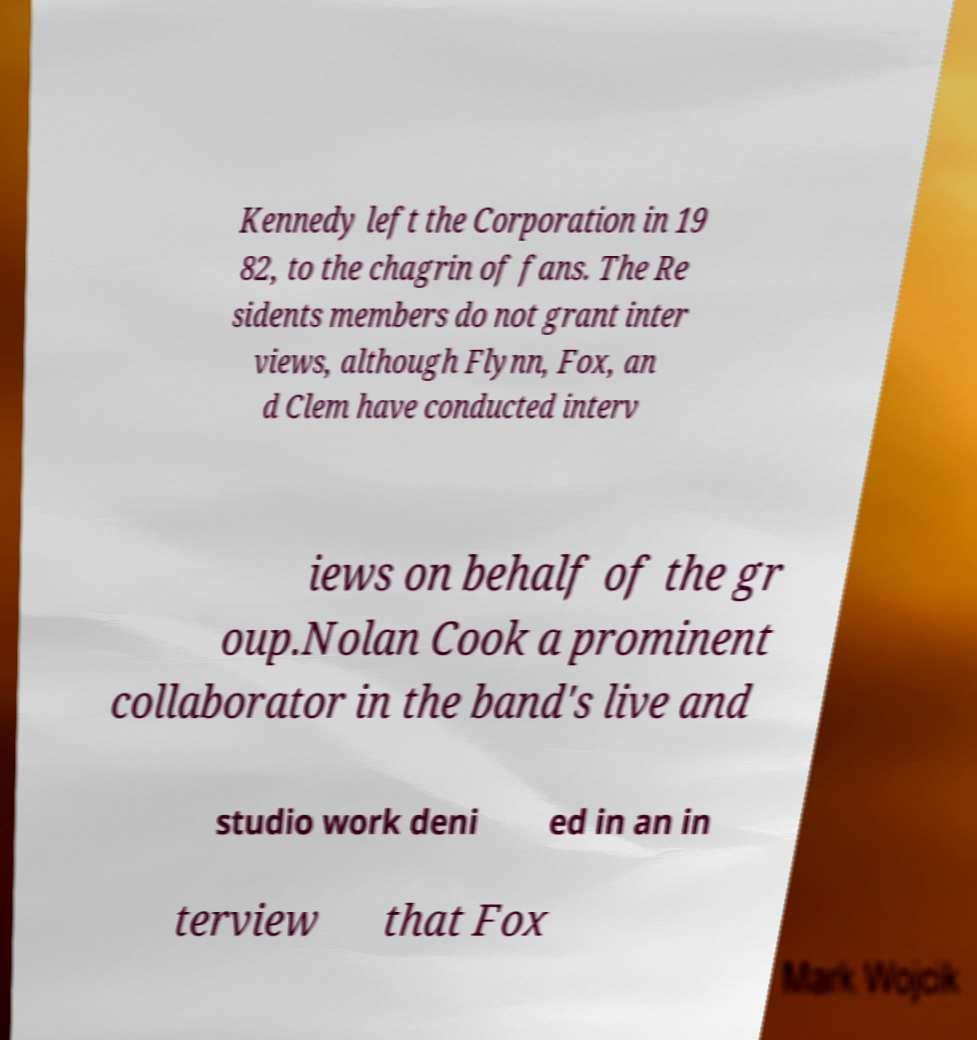Could you assist in decoding the text presented in this image and type it out clearly? Kennedy left the Corporation in 19 82, to the chagrin of fans. The Re sidents members do not grant inter views, although Flynn, Fox, an d Clem have conducted interv iews on behalf of the gr oup.Nolan Cook a prominent collaborator in the band's live and studio work deni ed in an in terview that Fox 